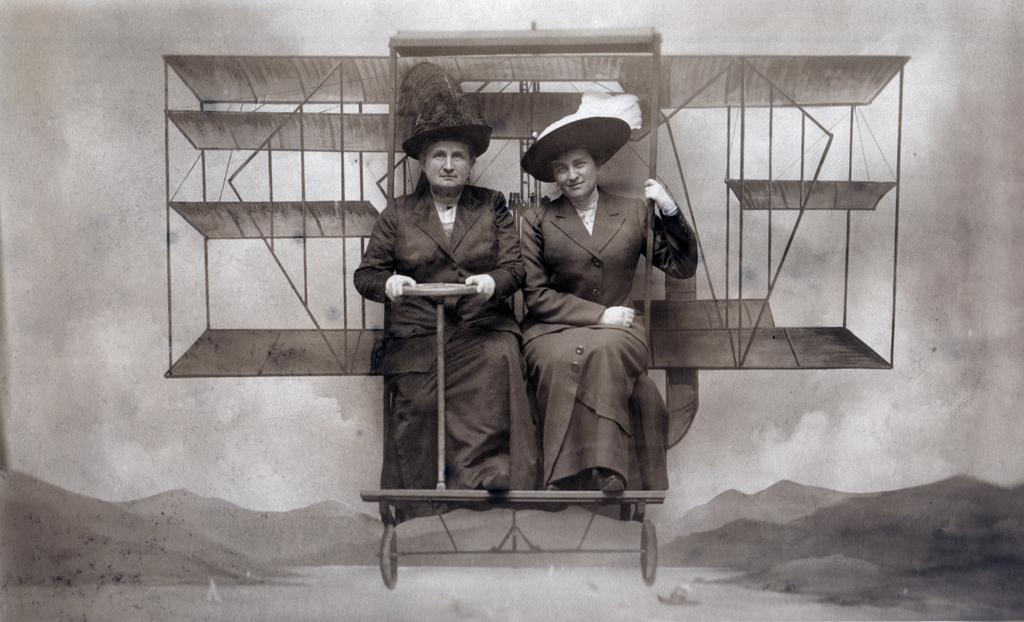What is the color scheme of the image? The image is black and white. What are the people in the image doing? The people are sitting on a stand in the image. What are the people wearing on their heads? The people are wearing hats. What can be seen behind the people? There is a wall visible in the image. What type of surface is at the bottom of the image? There is sand at the bottom of the image. What type of ground is visible in the image? There is ground visible in the image. What type of punishment is being administered to the crow in the image? There is no crow present in the image, and therefore no punishment is being administered. How many fingers does the person in the image have? The image is black and white, and it is not possible to determine the number of fingers the person has based on the available information. 